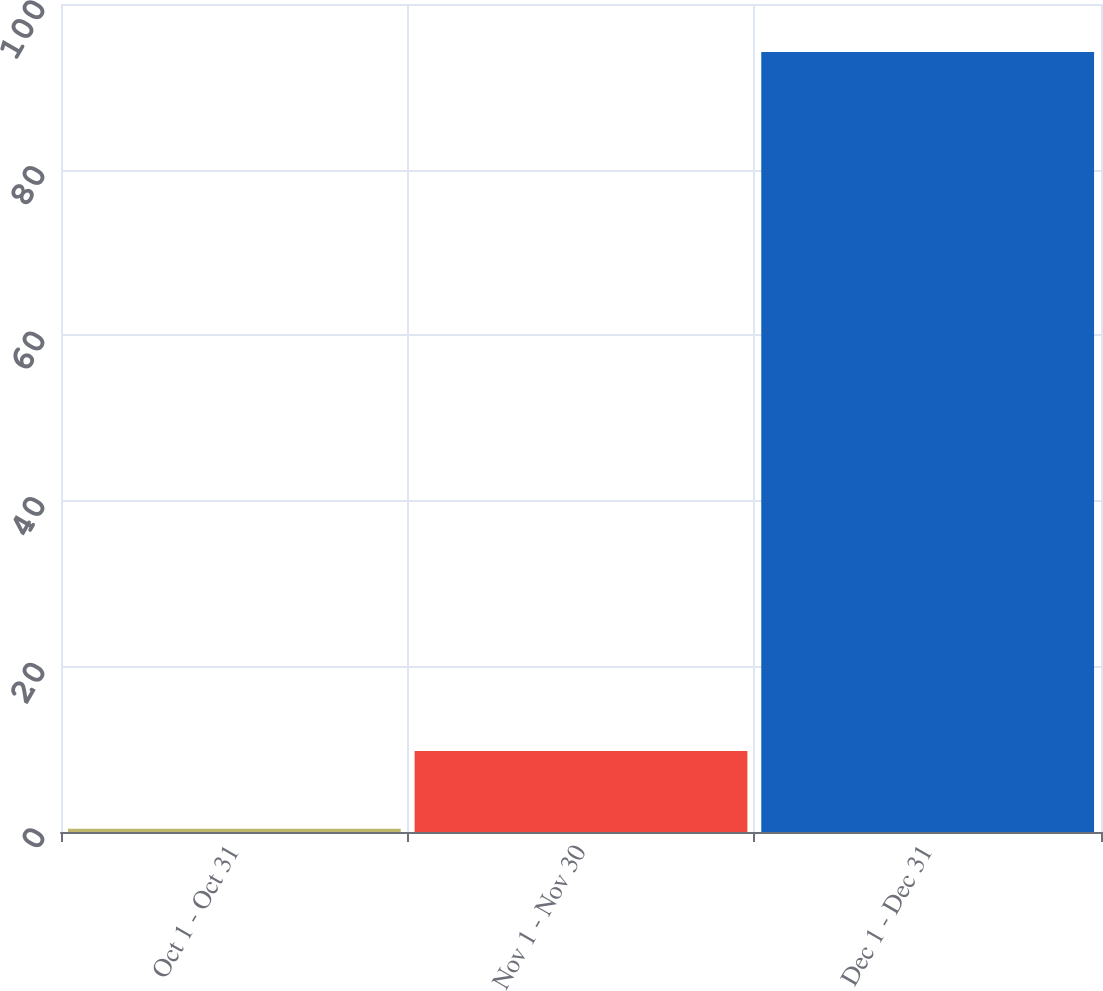<chart> <loc_0><loc_0><loc_500><loc_500><bar_chart><fcel>Oct 1 - Oct 31<fcel>Nov 1 - Nov 30<fcel>Dec 1 - Dec 31<nl><fcel>0.39<fcel>9.77<fcel>94.19<nl></chart> 